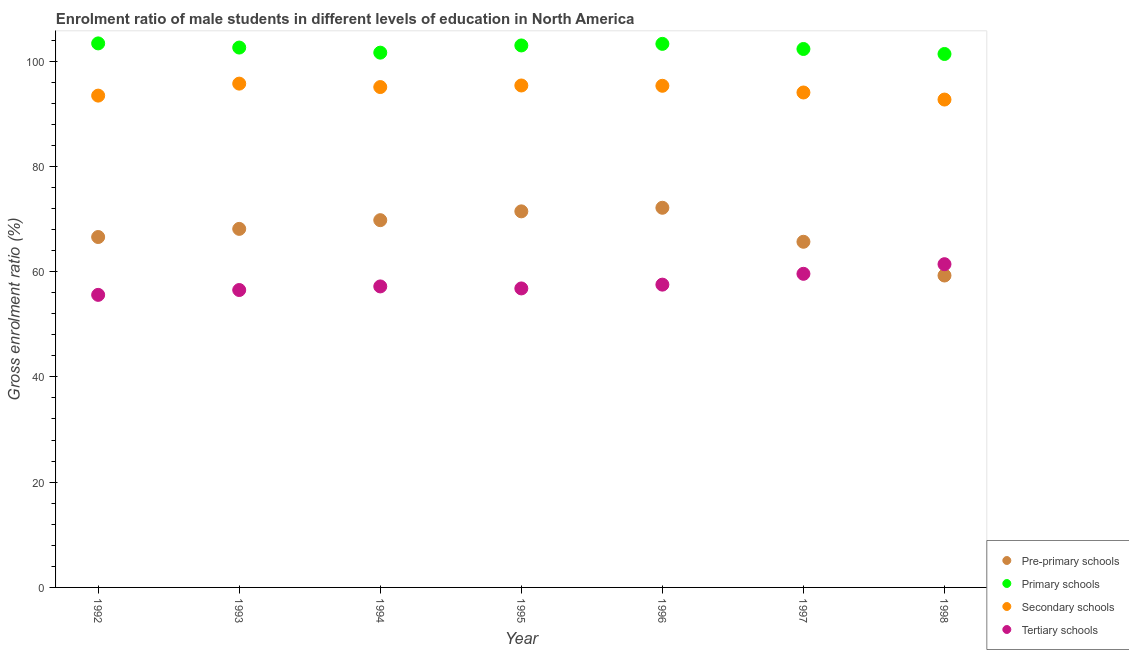How many different coloured dotlines are there?
Give a very brief answer. 4. What is the gross enrolment ratio(female) in pre-primary schools in 1993?
Give a very brief answer. 68.12. Across all years, what is the maximum gross enrolment ratio(female) in tertiary schools?
Your answer should be very brief. 61.41. Across all years, what is the minimum gross enrolment ratio(female) in tertiary schools?
Give a very brief answer. 55.58. In which year was the gross enrolment ratio(female) in pre-primary schools maximum?
Offer a very short reply. 1996. What is the total gross enrolment ratio(female) in secondary schools in the graph?
Keep it short and to the point. 661.6. What is the difference between the gross enrolment ratio(female) in secondary schools in 1994 and that in 1998?
Your response must be concise. 2.37. What is the difference between the gross enrolment ratio(female) in secondary schools in 1994 and the gross enrolment ratio(female) in tertiary schools in 1995?
Offer a very short reply. 38.26. What is the average gross enrolment ratio(female) in primary schools per year?
Your answer should be compact. 102.49. In the year 1995, what is the difference between the gross enrolment ratio(female) in pre-primary schools and gross enrolment ratio(female) in primary schools?
Provide a succinct answer. -31.52. In how many years, is the gross enrolment ratio(female) in secondary schools greater than 60 %?
Provide a succinct answer. 7. What is the ratio of the gross enrolment ratio(female) in primary schools in 1992 to that in 1994?
Provide a succinct answer. 1.02. What is the difference between the highest and the second highest gross enrolment ratio(female) in primary schools?
Your response must be concise. 0.09. What is the difference between the highest and the lowest gross enrolment ratio(female) in tertiary schools?
Your answer should be compact. 5.83. Is the sum of the gross enrolment ratio(female) in tertiary schools in 1992 and 1996 greater than the maximum gross enrolment ratio(female) in pre-primary schools across all years?
Your response must be concise. Yes. Is it the case that in every year, the sum of the gross enrolment ratio(female) in pre-primary schools and gross enrolment ratio(female) in primary schools is greater than the sum of gross enrolment ratio(female) in tertiary schools and gross enrolment ratio(female) in secondary schools?
Offer a terse response. Yes. Is it the case that in every year, the sum of the gross enrolment ratio(female) in pre-primary schools and gross enrolment ratio(female) in primary schools is greater than the gross enrolment ratio(female) in secondary schools?
Offer a terse response. Yes. What is the difference between two consecutive major ticks on the Y-axis?
Offer a terse response. 20. Does the graph contain grids?
Offer a terse response. No. How many legend labels are there?
Give a very brief answer. 4. What is the title of the graph?
Ensure brevity in your answer.  Enrolment ratio of male students in different levels of education in North America. Does "Energy" appear as one of the legend labels in the graph?
Offer a terse response. No. What is the label or title of the Y-axis?
Make the answer very short. Gross enrolment ratio (%). What is the Gross enrolment ratio (%) in Pre-primary schools in 1992?
Provide a short and direct response. 66.57. What is the Gross enrolment ratio (%) in Primary schools in 1992?
Offer a terse response. 103.36. What is the Gross enrolment ratio (%) in Secondary schools in 1992?
Keep it short and to the point. 93.44. What is the Gross enrolment ratio (%) of Tertiary schools in 1992?
Your answer should be compact. 55.58. What is the Gross enrolment ratio (%) in Pre-primary schools in 1993?
Your response must be concise. 68.12. What is the Gross enrolment ratio (%) of Primary schools in 1993?
Your response must be concise. 102.57. What is the Gross enrolment ratio (%) in Secondary schools in 1993?
Provide a short and direct response. 95.71. What is the Gross enrolment ratio (%) of Tertiary schools in 1993?
Your response must be concise. 56.5. What is the Gross enrolment ratio (%) of Pre-primary schools in 1994?
Your answer should be very brief. 69.77. What is the Gross enrolment ratio (%) in Primary schools in 1994?
Your answer should be very brief. 101.6. What is the Gross enrolment ratio (%) of Secondary schools in 1994?
Offer a very short reply. 95.06. What is the Gross enrolment ratio (%) in Tertiary schools in 1994?
Provide a succinct answer. 57.19. What is the Gross enrolment ratio (%) of Pre-primary schools in 1995?
Your answer should be compact. 71.45. What is the Gross enrolment ratio (%) in Primary schools in 1995?
Offer a terse response. 102.97. What is the Gross enrolment ratio (%) in Secondary schools in 1995?
Keep it short and to the point. 95.36. What is the Gross enrolment ratio (%) in Tertiary schools in 1995?
Offer a terse response. 56.8. What is the Gross enrolment ratio (%) of Pre-primary schools in 1996?
Offer a very short reply. 72.13. What is the Gross enrolment ratio (%) of Primary schools in 1996?
Offer a terse response. 103.27. What is the Gross enrolment ratio (%) in Secondary schools in 1996?
Keep it short and to the point. 95.3. What is the Gross enrolment ratio (%) of Tertiary schools in 1996?
Your answer should be compact. 57.53. What is the Gross enrolment ratio (%) of Pre-primary schools in 1997?
Your answer should be compact. 65.67. What is the Gross enrolment ratio (%) in Primary schools in 1997?
Provide a succinct answer. 102.29. What is the Gross enrolment ratio (%) of Secondary schools in 1997?
Offer a terse response. 94.03. What is the Gross enrolment ratio (%) in Tertiary schools in 1997?
Your response must be concise. 59.58. What is the Gross enrolment ratio (%) of Pre-primary schools in 1998?
Keep it short and to the point. 59.26. What is the Gross enrolment ratio (%) in Primary schools in 1998?
Keep it short and to the point. 101.35. What is the Gross enrolment ratio (%) of Secondary schools in 1998?
Your response must be concise. 92.69. What is the Gross enrolment ratio (%) in Tertiary schools in 1998?
Offer a very short reply. 61.41. Across all years, what is the maximum Gross enrolment ratio (%) of Pre-primary schools?
Offer a very short reply. 72.13. Across all years, what is the maximum Gross enrolment ratio (%) of Primary schools?
Offer a very short reply. 103.36. Across all years, what is the maximum Gross enrolment ratio (%) of Secondary schools?
Keep it short and to the point. 95.71. Across all years, what is the maximum Gross enrolment ratio (%) in Tertiary schools?
Your answer should be very brief. 61.41. Across all years, what is the minimum Gross enrolment ratio (%) of Pre-primary schools?
Keep it short and to the point. 59.26. Across all years, what is the minimum Gross enrolment ratio (%) of Primary schools?
Ensure brevity in your answer.  101.35. Across all years, what is the minimum Gross enrolment ratio (%) in Secondary schools?
Provide a short and direct response. 92.69. Across all years, what is the minimum Gross enrolment ratio (%) of Tertiary schools?
Your answer should be very brief. 55.58. What is the total Gross enrolment ratio (%) in Pre-primary schools in the graph?
Give a very brief answer. 472.96. What is the total Gross enrolment ratio (%) of Primary schools in the graph?
Offer a terse response. 717.4. What is the total Gross enrolment ratio (%) of Secondary schools in the graph?
Offer a terse response. 661.6. What is the total Gross enrolment ratio (%) in Tertiary schools in the graph?
Provide a succinct answer. 404.59. What is the difference between the Gross enrolment ratio (%) of Pre-primary schools in 1992 and that in 1993?
Ensure brevity in your answer.  -1.55. What is the difference between the Gross enrolment ratio (%) of Primary schools in 1992 and that in 1993?
Your answer should be compact. 0.79. What is the difference between the Gross enrolment ratio (%) in Secondary schools in 1992 and that in 1993?
Provide a succinct answer. -2.28. What is the difference between the Gross enrolment ratio (%) of Tertiary schools in 1992 and that in 1993?
Keep it short and to the point. -0.92. What is the difference between the Gross enrolment ratio (%) in Pre-primary schools in 1992 and that in 1994?
Provide a short and direct response. -3.2. What is the difference between the Gross enrolment ratio (%) of Primary schools in 1992 and that in 1994?
Offer a very short reply. 1.76. What is the difference between the Gross enrolment ratio (%) in Secondary schools in 1992 and that in 1994?
Offer a very short reply. -1.63. What is the difference between the Gross enrolment ratio (%) in Tertiary schools in 1992 and that in 1994?
Your answer should be compact. -1.6. What is the difference between the Gross enrolment ratio (%) of Pre-primary schools in 1992 and that in 1995?
Your response must be concise. -4.88. What is the difference between the Gross enrolment ratio (%) in Primary schools in 1992 and that in 1995?
Ensure brevity in your answer.  0.39. What is the difference between the Gross enrolment ratio (%) in Secondary schools in 1992 and that in 1995?
Provide a succinct answer. -1.92. What is the difference between the Gross enrolment ratio (%) in Tertiary schools in 1992 and that in 1995?
Offer a very short reply. -1.22. What is the difference between the Gross enrolment ratio (%) in Pre-primary schools in 1992 and that in 1996?
Your answer should be compact. -5.56. What is the difference between the Gross enrolment ratio (%) in Primary schools in 1992 and that in 1996?
Ensure brevity in your answer.  0.09. What is the difference between the Gross enrolment ratio (%) of Secondary schools in 1992 and that in 1996?
Make the answer very short. -1.87. What is the difference between the Gross enrolment ratio (%) of Tertiary schools in 1992 and that in 1996?
Make the answer very short. -1.94. What is the difference between the Gross enrolment ratio (%) of Pre-primary schools in 1992 and that in 1997?
Offer a very short reply. 0.9. What is the difference between the Gross enrolment ratio (%) in Primary schools in 1992 and that in 1997?
Provide a short and direct response. 1.06. What is the difference between the Gross enrolment ratio (%) of Secondary schools in 1992 and that in 1997?
Keep it short and to the point. -0.59. What is the difference between the Gross enrolment ratio (%) of Tertiary schools in 1992 and that in 1997?
Provide a succinct answer. -4. What is the difference between the Gross enrolment ratio (%) of Pre-primary schools in 1992 and that in 1998?
Your response must be concise. 7.32. What is the difference between the Gross enrolment ratio (%) in Primary schools in 1992 and that in 1998?
Provide a short and direct response. 2.01. What is the difference between the Gross enrolment ratio (%) in Secondary schools in 1992 and that in 1998?
Your answer should be very brief. 0.75. What is the difference between the Gross enrolment ratio (%) of Tertiary schools in 1992 and that in 1998?
Your answer should be compact. -5.83. What is the difference between the Gross enrolment ratio (%) in Pre-primary schools in 1993 and that in 1994?
Make the answer very short. -1.65. What is the difference between the Gross enrolment ratio (%) in Primary schools in 1993 and that in 1994?
Provide a short and direct response. 0.97. What is the difference between the Gross enrolment ratio (%) of Secondary schools in 1993 and that in 1994?
Provide a succinct answer. 0.65. What is the difference between the Gross enrolment ratio (%) in Tertiary schools in 1993 and that in 1994?
Offer a terse response. -0.68. What is the difference between the Gross enrolment ratio (%) in Pre-primary schools in 1993 and that in 1995?
Provide a short and direct response. -3.33. What is the difference between the Gross enrolment ratio (%) of Primary schools in 1993 and that in 1995?
Give a very brief answer. -0.4. What is the difference between the Gross enrolment ratio (%) of Secondary schools in 1993 and that in 1995?
Give a very brief answer. 0.35. What is the difference between the Gross enrolment ratio (%) of Tertiary schools in 1993 and that in 1995?
Your answer should be compact. -0.3. What is the difference between the Gross enrolment ratio (%) of Pre-primary schools in 1993 and that in 1996?
Your answer should be compact. -4.01. What is the difference between the Gross enrolment ratio (%) in Primary schools in 1993 and that in 1996?
Give a very brief answer. -0.7. What is the difference between the Gross enrolment ratio (%) in Secondary schools in 1993 and that in 1996?
Provide a short and direct response. 0.41. What is the difference between the Gross enrolment ratio (%) of Tertiary schools in 1993 and that in 1996?
Ensure brevity in your answer.  -1.02. What is the difference between the Gross enrolment ratio (%) in Pre-primary schools in 1993 and that in 1997?
Your response must be concise. 2.45. What is the difference between the Gross enrolment ratio (%) of Primary schools in 1993 and that in 1997?
Provide a short and direct response. 0.27. What is the difference between the Gross enrolment ratio (%) in Secondary schools in 1993 and that in 1997?
Provide a short and direct response. 1.68. What is the difference between the Gross enrolment ratio (%) in Tertiary schools in 1993 and that in 1997?
Ensure brevity in your answer.  -3.08. What is the difference between the Gross enrolment ratio (%) of Pre-primary schools in 1993 and that in 1998?
Offer a very short reply. 8.86. What is the difference between the Gross enrolment ratio (%) of Primary schools in 1993 and that in 1998?
Ensure brevity in your answer.  1.22. What is the difference between the Gross enrolment ratio (%) in Secondary schools in 1993 and that in 1998?
Your response must be concise. 3.02. What is the difference between the Gross enrolment ratio (%) in Tertiary schools in 1993 and that in 1998?
Offer a terse response. -4.91. What is the difference between the Gross enrolment ratio (%) in Pre-primary schools in 1994 and that in 1995?
Provide a short and direct response. -1.68. What is the difference between the Gross enrolment ratio (%) in Primary schools in 1994 and that in 1995?
Your answer should be very brief. -1.37. What is the difference between the Gross enrolment ratio (%) of Secondary schools in 1994 and that in 1995?
Provide a short and direct response. -0.3. What is the difference between the Gross enrolment ratio (%) of Tertiary schools in 1994 and that in 1995?
Offer a very short reply. 0.38. What is the difference between the Gross enrolment ratio (%) of Pre-primary schools in 1994 and that in 1996?
Keep it short and to the point. -2.36. What is the difference between the Gross enrolment ratio (%) in Primary schools in 1994 and that in 1996?
Your answer should be compact. -1.67. What is the difference between the Gross enrolment ratio (%) of Secondary schools in 1994 and that in 1996?
Offer a terse response. -0.24. What is the difference between the Gross enrolment ratio (%) of Tertiary schools in 1994 and that in 1996?
Provide a succinct answer. -0.34. What is the difference between the Gross enrolment ratio (%) of Pre-primary schools in 1994 and that in 1997?
Your answer should be very brief. 4.1. What is the difference between the Gross enrolment ratio (%) in Primary schools in 1994 and that in 1997?
Your answer should be compact. -0.7. What is the difference between the Gross enrolment ratio (%) in Secondary schools in 1994 and that in 1997?
Offer a very short reply. 1.03. What is the difference between the Gross enrolment ratio (%) of Tertiary schools in 1994 and that in 1997?
Your answer should be very brief. -2.4. What is the difference between the Gross enrolment ratio (%) of Pre-primary schools in 1994 and that in 1998?
Provide a short and direct response. 10.52. What is the difference between the Gross enrolment ratio (%) in Primary schools in 1994 and that in 1998?
Your answer should be compact. 0.25. What is the difference between the Gross enrolment ratio (%) of Secondary schools in 1994 and that in 1998?
Offer a terse response. 2.37. What is the difference between the Gross enrolment ratio (%) of Tertiary schools in 1994 and that in 1998?
Offer a terse response. -4.22. What is the difference between the Gross enrolment ratio (%) of Pre-primary schools in 1995 and that in 1996?
Offer a very short reply. -0.68. What is the difference between the Gross enrolment ratio (%) in Primary schools in 1995 and that in 1996?
Your answer should be very brief. -0.3. What is the difference between the Gross enrolment ratio (%) in Secondary schools in 1995 and that in 1996?
Offer a very short reply. 0.06. What is the difference between the Gross enrolment ratio (%) of Tertiary schools in 1995 and that in 1996?
Provide a short and direct response. -0.72. What is the difference between the Gross enrolment ratio (%) of Pre-primary schools in 1995 and that in 1997?
Give a very brief answer. 5.78. What is the difference between the Gross enrolment ratio (%) of Primary schools in 1995 and that in 1997?
Make the answer very short. 0.67. What is the difference between the Gross enrolment ratio (%) of Secondary schools in 1995 and that in 1997?
Your answer should be compact. 1.33. What is the difference between the Gross enrolment ratio (%) in Tertiary schools in 1995 and that in 1997?
Ensure brevity in your answer.  -2.78. What is the difference between the Gross enrolment ratio (%) in Pre-primary schools in 1995 and that in 1998?
Keep it short and to the point. 12.19. What is the difference between the Gross enrolment ratio (%) of Primary schools in 1995 and that in 1998?
Your response must be concise. 1.62. What is the difference between the Gross enrolment ratio (%) in Secondary schools in 1995 and that in 1998?
Keep it short and to the point. 2.67. What is the difference between the Gross enrolment ratio (%) of Tertiary schools in 1995 and that in 1998?
Your answer should be very brief. -4.6. What is the difference between the Gross enrolment ratio (%) in Pre-primary schools in 1996 and that in 1997?
Provide a succinct answer. 6.46. What is the difference between the Gross enrolment ratio (%) in Primary schools in 1996 and that in 1997?
Give a very brief answer. 0.97. What is the difference between the Gross enrolment ratio (%) in Secondary schools in 1996 and that in 1997?
Provide a succinct answer. 1.27. What is the difference between the Gross enrolment ratio (%) of Tertiary schools in 1996 and that in 1997?
Your answer should be very brief. -2.06. What is the difference between the Gross enrolment ratio (%) of Pre-primary schools in 1996 and that in 1998?
Your answer should be compact. 12.87. What is the difference between the Gross enrolment ratio (%) in Primary schools in 1996 and that in 1998?
Provide a short and direct response. 1.92. What is the difference between the Gross enrolment ratio (%) in Secondary schools in 1996 and that in 1998?
Keep it short and to the point. 2.61. What is the difference between the Gross enrolment ratio (%) in Tertiary schools in 1996 and that in 1998?
Your answer should be compact. -3.88. What is the difference between the Gross enrolment ratio (%) of Pre-primary schools in 1997 and that in 1998?
Make the answer very short. 6.41. What is the difference between the Gross enrolment ratio (%) of Primary schools in 1997 and that in 1998?
Offer a terse response. 0.95. What is the difference between the Gross enrolment ratio (%) in Secondary schools in 1997 and that in 1998?
Give a very brief answer. 1.34. What is the difference between the Gross enrolment ratio (%) in Tertiary schools in 1997 and that in 1998?
Your answer should be compact. -1.83. What is the difference between the Gross enrolment ratio (%) of Pre-primary schools in 1992 and the Gross enrolment ratio (%) of Primary schools in 1993?
Your answer should be very brief. -35.99. What is the difference between the Gross enrolment ratio (%) in Pre-primary schools in 1992 and the Gross enrolment ratio (%) in Secondary schools in 1993?
Your answer should be compact. -29.14. What is the difference between the Gross enrolment ratio (%) in Pre-primary schools in 1992 and the Gross enrolment ratio (%) in Tertiary schools in 1993?
Offer a very short reply. 10.07. What is the difference between the Gross enrolment ratio (%) of Primary schools in 1992 and the Gross enrolment ratio (%) of Secondary schools in 1993?
Your answer should be very brief. 7.64. What is the difference between the Gross enrolment ratio (%) of Primary schools in 1992 and the Gross enrolment ratio (%) of Tertiary schools in 1993?
Keep it short and to the point. 46.85. What is the difference between the Gross enrolment ratio (%) of Secondary schools in 1992 and the Gross enrolment ratio (%) of Tertiary schools in 1993?
Offer a very short reply. 36.93. What is the difference between the Gross enrolment ratio (%) of Pre-primary schools in 1992 and the Gross enrolment ratio (%) of Primary schools in 1994?
Your answer should be compact. -35.03. What is the difference between the Gross enrolment ratio (%) in Pre-primary schools in 1992 and the Gross enrolment ratio (%) in Secondary schools in 1994?
Keep it short and to the point. -28.49. What is the difference between the Gross enrolment ratio (%) in Pre-primary schools in 1992 and the Gross enrolment ratio (%) in Tertiary schools in 1994?
Provide a succinct answer. 9.39. What is the difference between the Gross enrolment ratio (%) in Primary schools in 1992 and the Gross enrolment ratio (%) in Secondary schools in 1994?
Offer a terse response. 8.29. What is the difference between the Gross enrolment ratio (%) in Primary schools in 1992 and the Gross enrolment ratio (%) in Tertiary schools in 1994?
Your answer should be very brief. 46.17. What is the difference between the Gross enrolment ratio (%) of Secondary schools in 1992 and the Gross enrolment ratio (%) of Tertiary schools in 1994?
Offer a very short reply. 36.25. What is the difference between the Gross enrolment ratio (%) in Pre-primary schools in 1992 and the Gross enrolment ratio (%) in Primary schools in 1995?
Your answer should be compact. -36.39. What is the difference between the Gross enrolment ratio (%) of Pre-primary schools in 1992 and the Gross enrolment ratio (%) of Secondary schools in 1995?
Provide a short and direct response. -28.79. What is the difference between the Gross enrolment ratio (%) of Pre-primary schools in 1992 and the Gross enrolment ratio (%) of Tertiary schools in 1995?
Your answer should be compact. 9.77. What is the difference between the Gross enrolment ratio (%) of Primary schools in 1992 and the Gross enrolment ratio (%) of Secondary schools in 1995?
Your answer should be very brief. 8. What is the difference between the Gross enrolment ratio (%) in Primary schools in 1992 and the Gross enrolment ratio (%) in Tertiary schools in 1995?
Keep it short and to the point. 46.55. What is the difference between the Gross enrolment ratio (%) in Secondary schools in 1992 and the Gross enrolment ratio (%) in Tertiary schools in 1995?
Ensure brevity in your answer.  36.63. What is the difference between the Gross enrolment ratio (%) in Pre-primary schools in 1992 and the Gross enrolment ratio (%) in Primary schools in 1996?
Keep it short and to the point. -36.7. What is the difference between the Gross enrolment ratio (%) of Pre-primary schools in 1992 and the Gross enrolment ratio (%) of Secondary schools in 1996?
Your answer should be very brief. -28.73. What is the difference between the Gross enrolment ratio (%) of Pre-primary schools in 1992 and the Gross enrolment ratio (%) of Tertiary schools in 1996?
Make the answer very short. 9.05. What is the difference between the Gross enrolment ratio (%) in Primary schools in 1992 and the Gross enrolment ratio (%) in Secondary schools in 1996?
Offer a very short reply. 8.05. What is the difference between the Gross enrolment ratio (%) of Primary schools in 1992 and the Gross enrolment ratio (%) of Tertiary schools in 1996?
Offer a terse response. 45.83. What is the difference between the Gross enrolment ratio (%) of Secondary schools in 1992 and the Gross enrolment ratio (%) of Tertiary schools in 1996?
Give a very brief answer. 35.91. What is the difference between the Gross enrolment ratio (%) in Pre-primary schools in 1992 and the Gross enrolment ratio (%) in Primary schools in 1997?
Your answer should be very brief. -35.72. What is the difference between the Gross enrolment ratio (%) in Pre-primary schools in 1992 and the Gross enrolment ratio (%) in Secondary schools in 1997?
Your answer should be very brief. -27.46. What is the difference between the Gross enrolment ratio (%) of Pre-primary schools in 1992 and the Gross enrolment ratio (%) of Tertiary schools in 1997?
Provide a succinct answer. 6.99. What is the difference between the Gross enrolment ratio (%) of Primary schools in 1992 and the Gross enrolment ratio (%) of Secondary schools in 1997?
Give a very brief answer. 9.33. What is the difference between the Gross enrolment ratio (%) of Primary schools in 1992 and the Gross enrolment ratio (%) of Tertiary schools in 1997?
Your response must be concise. 43.78. What is the difference between the Gross enrolment ratio (%) in Secondary schools in 1992 and the Gross enrolment ratio (%) in Tertiary schools in 1997?
Provide a short and direct response. 33.86. What is the difference between the Gross enrolment ratio (%) in Pre-primary schools in 1992 and the Gross enrolment ratio (%) in Primary schools in 1998?
Provide a succinct answer. -34.77. What is the difference between the Gross enrolment ratio (%) of Pre-primary schools in 1992 and the Gross enrolment ratio (%) of Secondary schools in 1998?
Your answer should be compact. -26.12. What is the difference between the Gross enrolment ratio (%) in Pre-primary schools in 1992 and the Gross enrolment ratio (%) in Tertiary schools in 1998?
Offer a very short reply. 5.16. What is the difference between the Gross enrolment ratio (%) of Primary schools in 1992 and the Gross enrolment ratio (%) of Secondary schools in 1998?
Your answer should be very brief. 10.67. What is the difference between the Gross enrolment ratio (%) of Primary schools in 1992 and the Gross enrolment ratio (%) of Tertiary schools in 1998?
Make the answer very short. 41.95. What is the difference between the Gross enrolment ratio (%) of Secondary schools in 1992 and the Gross enrolment ratio (%) of Tertiary schools in 1998?
Your answer should be compact. 32.03. What is the difference between the Gross enrolment ratio (%) of Pre-primary schools in 1993 and the Gross enrolment ratio (%) of Primary schools in 1994?
Offer a terse response. -33.48. What is the difference between the Gross enrolment ratio (%) of Pre-primary schools in 1993 and the Gross enrolment ratio (%) of Secondary schools in 1994?
Ensure brevity in your answer.  -26.95. What is the difference between the Gross enrolment ratio (%) of Pre-primary schools in 1993 and the Gross enrolment ratio (%) of Tertiary schools in 1994?
Offer a terse response. 10.93. What is the difference between the Gross enrolment ratio (%) of Primary schools in 1993 and the Gross enrolment ratio (%) of Secondary schools in 1994?
Make the answer very short. 7.5. What is the difference between the Gross enrolment ratio (%) in Primary schools in 1993 and the Gross enrolment ratio (%) in Tertiary schools in 1994?
Provide a succinct answer. 45.38. What is the difference between the Gross enrolment ratio (%) in Secondary schools in 1993 and the Gross enrolment ratio (%) in Tertiary schools in 1994?
Provide a short and direct response. 38.53. What is the difference between the Gross enrolment ratio (%) of Pre-primary schools in 1993 and the Gross enrolment ratio (%) of Primary schools in 1995?
Offer a terse response. -34.85. What is the difference between the Gross enrolment ratio (%) in Pre-primary schools in 1993 and the Gross enrolment ratio (%) in Secondary schools in 1995?
Your answer should be very brief. -27.24. What is the difference between the Gross enrolment ratio (%) of Pre-primary schools in 1993 and the Gross enrolment ratio (%) of Tertiary schools in 1995?
Provide a succinct answer. 11.31. What is the difference between the Gross enrolment ratio (%) of Primary schools in 1993 and the Gross enrolment ratio (%) of Secondary schools in 1995?
Offer a terse response. 7.21. What is the difference between the Gross enrolment ratio (%) in Primary schools in 1993 and the Gross enrolment ratio (%) in Tertiary schools in 1995?
Offer a terse response. 45.76. What is the difference between the Gross enrolment ratio (%) of Secondary schools in 1993 and the Gross enrolment ratio (%) of Tertiary schools in 1995?
Ensure brevity in your answer.  38.91. What is the difference between the Gross enrolment ratio (%) of Pre-primary schools in 1993 and the Gross enrolment ratio (%) of Primary schools in 1996?
Your answer should be very brief. -35.15. What is the difference between the Gross enrolment ratio (%) of Pre-primary schools in 1993 and the Gross enrolment ratio (%) of Secondary schools in 1996?
Provide a succinct answer. -27.19. What is the difference between the Gross enrolment ratio (%) in Pre-primary schools in 1993 and the Gross enrolment ratio (%) in Tertiary schools in 1996?
Your answer should be very brief. 10.59. What is the difference between the Gross enrolment ratio (%) in Primary schools in 1993 and the Gross enrolment ratio (%) in Secondary schools in 1996?
Keep it short and to the point. 7.26. What is the difference between the Gross enrolment ratio (%) of Primary schools in 1993 and the Gross enrolment ratio (%) of Tertiary schools in 1996?
Give a very brief answer. 45.04. What is the difference between the Gross enrolment ratio (%) of Secondary schools in 1993 and the Gross enrolment ratio (%) of Tertiary schools in 1996?
Your answer should be very brief. 38.19. What is the difference between the Gross enrolment ratio (%) of Pre-primary schools in 1993 and the Gross enrolment ratio (%) of Primary schools in 1997?
Offer a terse response. -34.18. What is the difference between the Gross enrolment ratio (%) in Pre-primary schools in 1993 and the Gross enrolment ratio (%) in Secondary schools in 1997?
Your answer should be very brief. -25.91. What is the difference between the Gross enrolment ratio (%) of Pre-primary schools in 1993 and the Gross enrolment ratio (%) of Tertiary schools in 1997?
Provide a succinct answer. 8.54. What is the difference between the Gross enrolment ratio (%) in Primary schools in 1993 and the Gross enrolment ratio (%) in Secondary schools in 1997?
Provide a succinct answer. 8.54. What is the difference between the Gross enrolment ratio (%) in Primary schools in 1993 and the Gross enrolment ratio (%) in Tertiary schools in 1997?
Provide a short and direct response. 42.98. What is the difference between the Gross enrolment ratio (%) in Secondary schools in 1993 and the Gross enrolment ratio (%) in Tertiary schools in 1997?
Offer a very short reply. 36.13. What is the difference between the Gross enrolment ratio (%) in Pre-primary schools in 1993 and the Gross enrolment ratio (%) in Primary schools in 1998?
Make the answer very short. -33.23. What is the difference between the Gross enrolment ratio (%) in Pre-primary schools in 1993 and the Gross enrolment ratio (%) in Secondary schools in 1998?
Your answer should be very brief. -24.57. What is the difference between the Gross enrolment ratio (%) of Pre-primary schools in 1993 and the Gross enrolment ratio (%) of Tertiary schools in 1998?
Your answer should be very brief. 6.71. What is the difference between the Gross enrolment ratio (%) of Primary schools in 1993 and the Gross enrolment ratio (%) of Secondary schools in 1998?
Your answer should be very brief. 9.88. What is the difference between the Gross enrolment ratio (%) of Primary schools in 1993 and the Gross enrolment ratio (%) of Tertiary schools in 1998?
Ensure brevity in your answer.  41.16. What is the difference between the Gross enrolment ratio (%) of Secondary schools in 1993 and the Gross enrolment ratio (%) of Tertiary schools in 1998?
Your answer should be very brief. 34.3. What is the difference between the Gross enrolment ratio (%) in Pre-primary schools in 1994 and the Gross enrolment ratio (%) in Primary schools in 1995?
Your answer should be compact. -33.19. What is the difference between the Gross enrolment ratio (%) of Pre-primary schools in 1994 and the Gross enrolment ratio (%) of Secondary schools in 1995?
Ensure brevity in your answer.  -25.59. What is the difference between the Gross enrolment ratio (%) of Pre-primary schools in 1994 and the Gross enrolment ratio (%) of Tertiary schools in 1995?
Your answer should be very brief. 12.97. What is the difference between the Gross enrolment ratio (%) of Primary schools in 1994 and the Gross enrolment ratio (%) of Secondary schools in 1995?
Your answer should be very brief. 6.24. What is the difference between the Gross enrolment ratio (%) of Primary schools in 1994 and the Gross enrolment ratio (%) of Tertiary schools in 1995?
Make the answer very short. 44.79. What is the difference between the Gross enrolment ratio (%) of Secondary schools in 1994 and the Gross enrolment ratio (%) of Tertiary schools in 1995?
Provide a succinct answer. 38.26. What is the difference between the Gross enrolment ratio (%) in Pre-primary schools in 1994 and the Gross enrolment ratio (%) in Primary schools in 1996?
Make the answer very short. -33.5. What is the difference between the Gross enrolment ratio (%) in Pre-primary schools in 1994 and the Gross enrolment ratio (%) in Secondary schools in 1996?
Your answer should be compact. -25.53. What is the difference between the Gross enrolment ratio (%) in Pre-primary schools in 1994 and the Gross enrolment ratio (%) in Tertiary schools in 1996?
Your answer should be compact. 12.25. What is the difference between the Gross enrolment ratio (%) in Primary schools in 1994 and the Gross enrolment ratio (%) in Secondary schools in 1996?
Provide a short and direct response. 6.29. What is the difference between the Gross enrolment ratio (%) in Primary schools in 1994 and the Gross enrolment ratio (%) in Tertiary schools in 1996?
Make the answer very short. 44.07. What is the difference between the Gross enrolment ratio (%) in Secondary schools in 1994 and the Gross enrolment ratio (%) in Tertiary schools in 1996?
Your answer should be very brief. 37.54. What is the difference between the Gross enrolment ratio (%) of Pre-primary schools in 1994 and the Gross enrolment ratio (%) of Primary schools in 1997?
Provide a succinct answer. -32.52. What is the difference between the Gross enrolment ratio (%) in Pre-primary schools in 1994 and the Gross enrolment ratio (%) in Secondary schools in 1997?
Your response must be concise. -24.26. What is the difference between the Gross enrolment ratio (%) in Pre-primary schools in 1994 and the Gross enrolment ratio (%) in Tertiary schools in 1997?
Provide a short and direct response. 10.19. What is the difference between the Gross enrolment ratio (%) of Primary schools in 1994 and the Gross enrolment ratio (%) of Secondary schools in 1997?
Your answer should be compact. 7.57. What is the difference between the Gross enrolment ratio (%) of Primary schools in 1994 and the Gross enrolment ratio (%) of Tertiary schools in 1997?
Offer a terse response. 42.02. What is the difference between the Gross enrolment ratio (%) in Secondary schools in 1994 and the Gross enrolment ratio (%) in Tertiary schools in 1997?
Offer a very short reply. 35.48. What is the difference between the Gross enrolment ratio (%) in Pre-primary schools in 1994 and the Gross enrolment ratio (%) in Primary schools in 1998?
Provide a succinct answer. -31.57. What is the difference between the Gross enrolment ratio (%) of Pre-primary schools in 1994 and the Gross enrolment ratio (%) of Secondary schools in 1998?
Keep it short and to the point. -22.92. What is the difference between the Gross enrolment ratio (%) of Pre-primary schools in 1994 and the Gross enrolment ratio (%) of Tertiary schools in 1998?
Offer a very short reply. 8.36. What is the difference between the Gross enrolment ratio (%) in Primary schools in 1994 and the Gross enrolment ratio (%) in Secondary schools in 1998?
Make the answer very short. 8.91. What is the difference between the Gross enrolment ratio (%) of Primary schools in 1994 and the Gross enrolment ratio (%) of Tertiary schools in 1998?
Provide a succinct answer. 40.19. What is the difference between the Gross enrolment ratio (%) of Secondary schools in 1994 and the Gross enrolment ratio (%) of Tertiary schools in 1998?
Give a very brief answer. 33.65. What is the difference between the Gross enrolment ratio (%) of Pre-primary schools in 1995 and the Gross enrolment ratio (%) of Primary schools in 1996?
Your answer should be compact. -31.82. What is the difference between the Gross enrolment ratio (%) of Pre-primary schools in 1995 and the Gross enrolment ratio (%) of Secondary schools in 1996?
Keep it short and to the point. -23.86. What is the difference between the Gross enrolment ratio (%) of Pre-primary schools in 1995 and the Gross enrolment ratio (%) of Tertiary schools in 1996?
Ensure brevity in your answer.  13.92. What is the difference between the Gross enrolment ratio (%) of Primary schools in 1995 and the Gross enrolment ratio (%) of Secondary schools in 1996?
Provide a short and direct response. 7.66. What is the difference between the Gross enrolment ratio (%) of Primary schools in 1995 and the Gross enrolment ratio (%) of Tertiary schools in 1996?
Make the answer very short. 45.44. What is the difference between the Gross enrolment ratio (%) of Secondary schools in 1995 and the Gross enrolment ratio (%) of Tertiary schools in 1996?
Your response must be concise. 37.84. What is the difference between the Gross enrolment ratio (%) in Pre-primary schools in 1995 and the Gross enrolment ratio (%) in Primary schools in 1997?
Keep it short and to the point. -30.85. What is the difference between the Gross enrolment ratio (%) of Pre-primary schools in 1995 and the Gross enrolment ratio (%) of Secondary schools in 1997?
Your answer should be very brief. -22.58. What is the difference between the Gross enrolment ratio (%) in Pre-primary schools in 1995 and the Gross enrolment ratio (%) in Tertiary schools in 1997?
Your response must be concise. 11.87. What is the difference between the Gross enrolment ratio (%) in Primary schools in 1995 and the Gross enrolment ratio (%) in Secondary schools in 1997?
Provide a succinct answer. 8.94. What is the difference between the Gross enrolment ratio (%) in Primary schools in 1995 and the Gross enrolment ratio (%) in Tertiary schools in 1997?
Keep it short and to the point. 43.39. What is the difference between the Gross enrolment ratio (%) of Secondary schools in 1995 and the Gross enrolment ratio (%) of Tertiary schools in 1997?
Provide a succinct answer. 35.78. What is the difference between the Gross enrolment ratio (%) in Pre-primary schools in 1995 and the Gross enrolment ratio (%) in Primary schools in 1998?
Your answer should be compact. -29.9. What is the difference between the Gross enrolment ratio (%) of Pre-primary schools in 1995 and the Gross enrolment ratio (%) of Secondary schools in 1998?
Offer a very short reply. -21.24. What is the difference between the Gross enrolment ratio (%) in Pre-primary schools in 1995 and the Gross enrolment ratio (%) in Tertiary schools in 1998?
Your answer should be very brief. 10.04. What is the difference between the Gross enrolment ratio (%) of Primary schools in 1995 and the Gross enrolment ratio (%) of Secondary schools in 1998?
Give a very brief answer. 10.28. What is the difference between the Gross enrolment ratio (%) of Primary schools in 1995 and the Gross enrolment ratio (%) of Tertiary schools in 1998?
Offer a terse response. 41.56. What is the difference between the Gross enrolment ratio (%) of Secondary schools in 1995 and the Gross enrolment ratio (%) of Tertiary schools in 1998?
Offer a terse response. 33.95. What is the difference between the Gross enrolment ratio (%) of Pre-primary schools in 1996 and the Gross enrolment ratio (%) of Primary schools in 1997?
Your answer should be compact. -30.17. What is the difference between the Gross enrolment ratio (%) in Pre-primary schools in 1996 and the Gross enrolment ratio (%) in Secondary schools in 1997?
Offer a very short reply. -21.9. What is the difference between the Gross enrolment ratio (%) of Pre-primary schools in 1996 and the Gross enrolment ratio (%) of Tertiary schools in 1997?
Your response must be concise. 12.55. What is the difference between the Gross enrolment ratio (%) in Primary schools in 1996 and the Gross enrolment ratio (%) in Secondary schools in 1997?
Keep it short and to the point. 9.24. What is the difference between the Gross enrolment ratio (%) in Primary schools in 1996 and the Gross enrolment ratio (%) in Tertiary schools in 1997?
Make the answer very short. 43.69. What is the difference between the Gross enrolment ratio (%) of Secondary schools in 1996 and the Gross enrolment ratio (%) of Tertiary schools in 1997?
Offer a very short reply. 35.72. What is the difference between the Gross enrolment ratio (%) of Pre-primary schools in 1996 and the Gross enrolment ratio (%) of Primary schools in 1998?
Your response must be concise. -29.22. What is the difference between the Gross enrolment ratio (%) of Pre-primary schools in 1996 and the Gross enrolment ratio (%) of Secondary schools in 1998?
Offer a terse response. -20.56. What is the difference between the Gross enrolment ratio (%) of Pre-primary schools in 1996 and the Gross enrolment ratio (%) of Tertiary schools in 1998?
Your answer should be compact. 10.72. What is the difference between the Gross enrolment ratio (%) of Primary schools in 1996 and the Gross enrolment ratio (%) of Secondary schools in 1998?
Keep it short and to the point. 10.58. What is the difference between the Gross enrolment ratio (%) in Primary schools in 1996 and the Gross enrolment ratio (%) in Tertiary schools in 1998?
Make the answer very short. 41.86. What is the difference between the Gross enrolment ratio (%) in Secondary schools in 1996 and the Gross enrolment ratio (%) in Tertiary schools in 1998?
Give a very brief answer. 33.89. What is the difference between the Gross enrolment ratio (%) in Pre-primary schools in 1997 and the Gross enrolment ratio (%) in Primary schools in 1998?
Make the answer very short. -35.68. What is the difference between the Gross enrolment ratio (%) of Pre-primary schools in 1997 and the Gross enrolment ratio (%) of Secondary schools in 1998?
Provide a short and direct response. -27.02. What is the difference between the Gross enrolment ratio (%) in Pre-primary schools in 1997 and the Gross enrolment ratio (%) in Tertiary schools in 1998?
Keep it short and to the point. 4.26. What is the difference between the Gross enrolment ratio (%) in Primary schools in 1997 and the Gross enrolment ratio (%) in Secondary schools in 1998?
Offer a very short reply. 9.61. What is the difference between the Gross enrolment ratio (%) of Primary schools in 1997 and the Gross enrolment ratio (%) of Tertiary schools in 1998?
Ensure brevity in your answer.  40.89. What is the difference between the Gross enrolment ratio (%) of Secondary schools in 1997 and the Gross enrolment ratio (%) of Tertiary schools in 1998?
Provide a short and direct response. 32.62. What is the average Gross enrolment ratio (%) of Pre-primary schools per year?
Make the answer very short. 67.57. What is the average Gross enrolment ratio (%) of Primary schools per year?
Provide a short and direct response. 102.49. What is the average Gross enrolment ratio (%) in Secondary schools per year?
Make the answer very short. 94.51. What is the average Gross enrolment ratio (%) of Tertiary schools per year?
Ensure brevity in your answer.  57.8. In the year 1992, what is the difference between the Gross enrolment ratio (%) in Pre-primary schools and Gross enrolment ratio (%) in Primary schools?
Provide a short and direct response. -36.78. In the year 1992, what is the difference between the Gross enrolment ratio (%) in Pre-primary schools and Gross enrolment ratio (%) in Secondary schools?
Ensure brevity in your answer.  -26.86. In the year 1992, what is the difference between the Gross enrolment ratio (%) in Pre-primary schools and Gross enrolment ratio (%) in Tertiary schools?
Your response must be concise. 10.99. In the year 1992, what is the difference between the Gross enrolment ratio (%) of Primary schools and Gross enrolment ratio (%) of Secondary schools?
Provide a succinct answer. 9.92. In the year 1992, what is the difference between the Gross enrolment ratio (%) in Primary schools and Gross enrolment ratio (%) in Tertiary schools?
Provide a succinct answer. 47.77. In the year 1992, what is the difference between the Gross enrolment ratio (%) of Secondary schools and Gross enrolment ratio (%) of Tertiary schools?
Offer a terse response. 37.85. In the year 1993, what is the difference between the Gross enrolment ratio (%) of Pre-primary schools and Gross enrolment ratio (%) of Primary schools?
Ensure brevity in your answer.  -34.45. In the year 1993, what is the difference between the Gross enrolment ratio (%) of Pre-primary schools and Gross enrolment ratio (%) of Secondary schools?
Provide a short and direct response. -27.6. In the year 1993, what is the difference between the Gross enrolment ratio (%) in Pre-primary schools and Gross enrolment ratio (%) in Tertiary schools?
Your answer should be very brief. 11.61. In the year 1993, what is the difference between the Gross enrolment ratio (%) of Primary schools and Gross enrolment ratio (%) of Secondary schools?
Offer a very short reply. 6.85. In the year 1993, what is the difference between the Gross enrolment ratio (%) in Primary schools and Gross enrolment ratio (%) in Tertiary schools?
Offer a terse response. 46.06. In the year 1993, what is the difference between the Gross enrolment ratio (%) of Secondary schools and Gross enrolment ratio (%) of Tertiary schools?
Ensure brevity in your answer.  39.21. In the year 1994, what is the difference between the Gross enrolment ratio (%) of Pre-primary schools and Gross enrolment ratio (%) of Primary schools?
Your answer should be very brief. -31.83. In the year 1994, what is the difference between the Gross enrolment ratio (%) of Pre-primary schools and Gross enrolment ratio (%) of Secondary schools?
Make the answer very short. -25.29. In the year 1994, what is the difference between the Gross enrolment ratio (%) of Pre-primary schools and Gross enrolment ratio (%) of Tertiary schools?
Your response must be concise. 12.59. In the year 1994, what is the difference between the Gross enrolment ratio (%) in Primary schools and Gross enrolment ratio (%) in Secondary schools?
Provide a short and direct response. 6.53. In the year 1994, what is the difference between the Gross enrolment ratio (%) in Primary schools and Gross enrolment ratio (%) in Tertiary schools?
Give a very brief answer. 44.41. In the year 1994, what is the difference between the Gross enrolment ratio (%) in Secondary schools and Gross enrolment ratio (%) in Tertiary schools?
Offer a very short reply. 37.88. In the year 1995, what is the difference between the Gross enrolment ratio (%) in Pre-primary schools and Gross enrolment ratio (%) in Primary schools?
Provide a succinct answer. -31.52. In the year 1995, what is the difference between the Gross enrolment ratio (%) in Pre-primary schools and Gross enrolment ratio (%) in Secondary schools?
Keep it short and to the point. -23.91. In the year 1995, what is the difference between the Gross enrolment ratio (%) of Pre-primary schools and Gross enrolment ratio (%) of Tertiary schools?
Your answer should be very brief. 14.64. In the year 1995, what is the difference between the Gross enrolment ratio (%) of Primary schools and Gross enrolment ratio (%) of Secondary schools?
Give a very brief answer. 7.61. In the year 1995, what is the difference between the Gross enrolment ratio (%) of Primary schools and Gross enrolment ratio (%) of Tertiary schools?
Ensure brevity in your answer.  46.16. In the year 1995, what is the difference between the Gross enrolment ratio (%) in Secondary schools and Gross enrolment ratio (%) in Tertiary schools?
Provide a succinct answer. 38.56. In the year 1996, what is the difference between the Gross enrolment ratio (%) of Pre-primary schools and Gross enrolment ratio (%) of Primary schools?
Offer a terse response. -31.14. In the year 1996, what is the difference between the Gross enrolment ratio (%) of Pre-primary schools and Gross enrolment ratio (%) of Secondary schools?
Provide a succinct answer. -23.17. In the year 1996, what is the difference between the Gross enrolment ratio (%) of Pre-primary schools and Gross enrolment ratio (%) of Tertiary schools?
Give a very brief answer. 14.6. In the year 1996, what is the difference between the Gross enrolment ratio (%) in Primary schools and Gross enrolment ratio (%) in Secondary schools?
Keep it short and to the point. 7.97. In the year 1996, what is the difference between the Gross enrolment ratio (%) in Primary schools and Gross enrolment ratio (%) in Tertiary schools?
Offer a terse response. 45.74. In the year 1996, what is the difference between the Gross enrolment ratio (%) of Secondary schools and Gross enrolment ratio (%) of Tertiary schools?
Keep it short and to the point. 37.78. In the year 1997, what is the difference between the Gross enrolment ratio (%) of Pre-primary schools and Gross enrolment ratio (%) of Primary schools?
Provide a succinct answer. -36.63. In the year 1997, what is the difference between the Gross enrolment ratio (%) in Pre-primary schools and Gross enrolment ratio (%) in Secondary schools?
Offer a very short reply. -28.36. In the year 1997, what is the difference between the Gross enrolment ratio (%) of Pre-primary schools and Gross enrolment ratio (%) of Tertiary schools?
Your answer should be compact. 6.09. In the year 1997, what is the difference between the Gross enrolment ratio (%) of Primary schools and Gross enrolment ratio (%) of Secondary schools?
Keep it short and to the point. 8.27. In the year 1997, what is the difference between the Gross enrolment ratio (%) of Primary schools and Gross enrolment ratio (%) of Tertiary schools?
Your answer should be compact. 42.71. In the year 1997, what is the difference between the Gross enrolment ratio (%) in Secondary schools and Gross enrolment ratio (%) in Tertiary schools?
Give a very brief answer. 34.45. In the year 1998, what is the difference between the Gross enrolment ratio (%) of Pre-primary schools and Gross enrolment ratio (%) of Primary schools?
Your answer should be compact. -42.09. In the year 1998, what is the difference between the Gross enrolment ratio (%) in Pre-primary schools and Gross enrolment ratio (%) in Secondary schools?
Ensure brevity in your answer.  -33.43. In the year 1998, what is the difference between the Gross enrolment ratio (%) in Pre-primary schools and Gross enrolment ratio (%) in Tertiary schools?
Offer a terse response. -2.15. In the year 1998, what is the difference between the Gross enrolment ratio (%) in Primary schools and Gross enrolment ratio (%) in Secondary schools?
Give a very brief answer. 8.66. In the year 1998, what is the difference between the Gross enrolment ratio (%) of Primary schools and Gross enrolment ratio (%) of Tertiary schools?
Provide a short and direct response. 39.94. In the year 1998, what is the difference between the Gross enrolment ratio (%) of Secondary schools and Gross enrolment ratio (%) of Tertiary schools?
Offer a very short reply. 31.28. What is the ratio of the Gross enrolment ratio (%) of Pre-primary schools in 1992 to that in 1993?
Offer a very short reply. 0.98. What is the ratio of the Gross enrolment ratio (%) of Primary schools in 1992 to that in 1993?
Provide a succinct answer. 1.01. What is the ratio of the Gross enrolment ratio (%) of Secondary schools in 1992 to that in 1993?
Offer a terse response. 0.98. What is the ratio of the Gross enrolment ratio (%) of Tertiary schools in 1992 to that in 1993?
Ensure brevity in your answer.  0.98. What is the ratio of the Gross enrolment ratio (%) of Pre-primary schools in 1992 to that in 1994?
Give a very brief answer. 0.95. What is the ratio of the Gross enrolment ratio (%) in Primary schools in 1992 to that in 1994?
Your answer should be very brief. 1.02. What is the ratio of the Gross enrolment ratio (%) of Secondary schools in 1992 to that in 1994?
Ensure brevity in your answer.  0.98. What is the ratio of the Gross enrolment ratio (%) of Pre-primary schools in 1992 to that in 1995?
Your response must be concise. 0.93. What is the ratio of the Gross enrolment ratio (%) in Secondary schools in 1992 to that in 1995?
Offer a terse response. 0.98. What is the ratio of the Gross enrolment ratio (%) in Tertiary schools in 1992 to that in 1995?
Give a very brief answer. 0.98. What is the ratio of the Gross enrolment ratio (%) in Pre-primary schools in 1992 to that in 1996?
Keep it short and to the point. 0.92. What is the ratio of the Gross enrolment ratio (%) of Primary schools in 1992 to that in 1996?
Your answer should be very brief. 1. What is the ratio of the Gross enrolment ratio (%) of Secondary schools in 1992 to that in 1996?
Provide a succinct answer. 0.98. What is the ratio of the Gross enrolment ratio (%) in Tertiary schools in 1992 to that in 1996?
Provide a short and direct response. 0.97. What is the ratio of the Gross enrolment ratio (%) of Pre-primary schools in 1992 to that in 1997?
Keep it short and to the point. 1.01. What is the ratio of the Gross enrolment ratio (%) in Primary schools in 1992 to that in 1997?
Your answer should be compact. 1.01. What is the ratio of the Gross enrolment ratio (%) in Tertiary schools in 1992 to that in 1997?
Provide a short and direct response. 0.93. What is the ratio of the Gross enrolment ratio (%) of Pre-primary schools in 1992 to that in 1998?
Your answer should be compact. 1.12. What is the ratio of the Gross enrolment ratio (%) of Primary schools in 1992 to that in 1998?
Provide a succinct answer. 1.02. What is the ratio of the Gross enrolment ratio (%) in Tertiary schools in 1992 to that in 1998?
Your response must be concise. 0.91. What is the ratio of the Gross enrolment ratio (%) of Pre-primary schools in 1993 to that in 1994?
Provide a short and direct response. 0.98. What is the ratio of the Gross enrolment ratio (%) of Primary schools in 1993 to that in 1994?
Keep it short and to the point. 1.01. What is the ratio of the Gross enrolment ratio (%) in Secondary schools in 1993 to that in 1994?
Your response must be concise. 1.01. What is the ratio of the Gross enrolment ratio (%) of Pre-primary schools in 1993 to that in 1995?
Your answer should be compact. 0.95. What is the ratio of the Gross enrolment ratio (%) in Primary schools in 1993 to that in 1995?
Your answer should be very brief. 1. What is the ratio of the Gross enrolment ratio (%) in Pre-primary schools in 1993 to that in 1996?
Make the answer very short. 0.94. What is the ratio of the Gross enrolment ratio (%) in Primary schools in 1993 to that in 1996?
Offer a very short reply. 0.99. What is the ratio of the Gross enrolment ratio (%) in Tertiary schools in 1993 to that in 1996?
Your answer should be compact. 0.98. What is the ratio of the Gross enrolment ratio (%) of Pre-primary schools in 1993 to that in 1997?
Provide a succinct answer. 1.04. What is the ratio of the Gross enrolment ratio (%) in Secondary schools in 1993 to that in 1997?
Offer a terse response. 1.02. What is the ratio of the Gross enrolment ratio (%) of Tertiary schools in 1993 to that in 1997?
Provide a succinct answer. 0.95. What is the ratio of the Gross enrolment ratio (%) of Pre-primary schools in 1993 to that in 1998?
Your answer should be very brief. 1.15. What is the ratio of the Gross enrolment ratio (%) of Primary schools in 1993 to that in 1998?
Offer a terse response. 1.01. What is the ratio of the Gross enrolment ratio (%) in Secondary schools in 1993 to that in 1998?
Make the answer very short. 1.03. What is the ratio of the Gross enrolment ratio (%) in Tertiary schools in 1993 to that in 1998?
Offer a very short reply. 0.92. What is the ratio of the Gross enrolment ratio (%) in Pre-primary schools in 1994 to that in 1995?
Offer a terse response. 0.98. What is the ratio of the Gross enrolment ratio (%) in Primary schools in 1994 to that in 1995?
Offer a terse response. 0.99. What is the ratio of the Gross enrolment ratio (%) of Tertiary schools in 1994 to that in 1995?
Your answer should be compact. 1.01. What is the ratio of the Gross enrolment ratio (%) in Pre-primary schools in 1994 to that in 1996?
Your answer should be compact. 0.97. What is the ratio of the Gross enrolment ratio (%) of Primary schools in 1994 to that in 1996?
Your response must be concise. 0.98. What is the ratio of the Gross enrolment ratio (%) in Tertiary schools in 1994 to that in 1996?
Provide a succinct answer. 0.99. What is the ratio of the Gross enrolment ratio (%) of Tertiary schools in 1994 to that in 1997?
Offer a very short reply. 0.96. What is the ratio of the Gross enrolment ratio (%) of Pre-primary schools in 1994 to that in 1998?
Your answer should be compact. 1.18. What is the ratio of the Gross enrolment ratio (%) in Secondary schools in 1994 to that in 1998?
Your answer should be very brief. 1.03. What is the ratio of the Gross enrolment ratio (%) of Tertiary schools in 1994 to that in 1998?
Keep it short and to the point. 0.93. What is the ratio of the Gross enrolment ratio (%) of Pre-primary schools in 1995 to that in 1996?
Provide a succinct answer. 0.99. What is the ratio of the Gross enrolment ratio (%) in Primary schools in 1995 to that in 1996?
Ensure brevity in your answer.  1. What is the ratio of the Gross enrolment ratio (%) of Secondary schools in 1995 to that in 1996?
Make the answer very short. 1. What is the ratio of the Gross enrolment ratio (%) in Tertiary schools in 1995 to that in 1996?
Ensure brevity in your answer.  0.99. What is the ratio of the Gross enrolment ratio (%) of Pre-primary schools in 1995 to that in 1997?
Your answer should be compact. 1.09. What is the ratio of the Gross enrolment ratio (%) in Primary schools in 1995 to that in 1997?
Ensure brevity in your answer.  1.01. What is the ratio of the Gross enrolment ratio (%) in Secondary schools in 1995 to that in 1997?
Provide a short and direct response. 1.01. What is the ratio of the Gross enrolment ratio (%) in Tertiary schools in 1995 to that in 1997?
Keep it short and to the point. 0.95. What is the ratio of the Gross enrolment ratio (%) in Pre-primary schools in 1995 to that in 1998?
Keep it short and to the point. 1.21. What is the ratio of the Gross enrolment ratio (%) of Secondary schools in 1995 to that in 1998?
Keep it short and to the point. 1.03. What is the ratio of the Gross enrolment ratio (%) of Tertiary schools in 1995 to that in 1998?
Your answer should be very brief. 0.93. What is the ratio of the Gross enrolment ratio (%) in Pre-primary schools in 1996 to that in 1997?
Your answer should be compact. 1.1. What is the ratio of the Gross enrolment ratio (%) in Primary schools in 1996 to that in 1997?
Keep it short and to the point. 1.01. What is the ratio of the Gross enrolment ratio (%) in Secondary schools in 1996 to that in 1997?
Provide a succinct answer. 1.01. What is the ratio of the Gross enrolment ratio (%) of Tertiary schools in 1996 to that in 1997?
Your answer should be very brief. 0.97. What is the ratio of the Gross enrolment ratio (%) in Pre-primary schools in 1996 to that in 1998?
Offer a very short reply. 1.22. What is the ratio of the Gross enrolment ratio (%) of Secondary schools in 1996 to that in 1998?
Your answer should be very brief. 1.03. What is the ratio of the Gross enrolment ratio (%) of Tertiary schools in 1996 to that in 1998?
Make the answer very short. 0.94. What is the ratio of the Gross enrolment ratio (%) of Pre-primary schools in 1997 to that in 1998?
Offer a very short reply. 1.11. What is the ratio of the Gross enrolment ratio (%) of Primary schools in 1997 to that in 1998?
Keep it short and to the point. 1.01. What is the ratio of the Gross enrolment ratio (%) in Secondary schools in 1997 to that in 1998?
Provide a succinct answer. 1.01. What is the ratio of the Gross enrolment ratio (%) in Tertiary schools in 1997 to that in 1998?
Provide a succinct answer. 0.97. What is the difference between the highest and the second highest Gross enrolment ratio (%) of Pre-primary schools?
Offer a terse response. 0.68. What is the difference between the highest and the second highest Gross enrolment ratio (%) in Primary schools?
Your answer should be very brief. 0.09. What is the difference between the highest and the second highest Gross enrolment ratio (%) in Secondary schools?
Provide a succinct answer. 0.35. What is the difference between the highest and the second highest Gross enrolment ratio (%) in Tertiary schools?
Offer a very short reply. 1.83. What is the difference between the highest and the lowest Gross enrolment ratio (%) in Pre-primary schools?
Provide a succinct answer. 12.87. What is the difference between the highest and the lowest Gross enrolment ratio (%) of Primary schools?
Make the answer very short. 2.01. What is the difference between the highest and the lowest Gross enrolment ratio (%) in Secondary schools?
Offer a terse response. 3.02. What is the difference between the highest and the lowest Gross enrolment ratio (%) of Tertiary schools?
Your answer should be very brief. 5.83. 